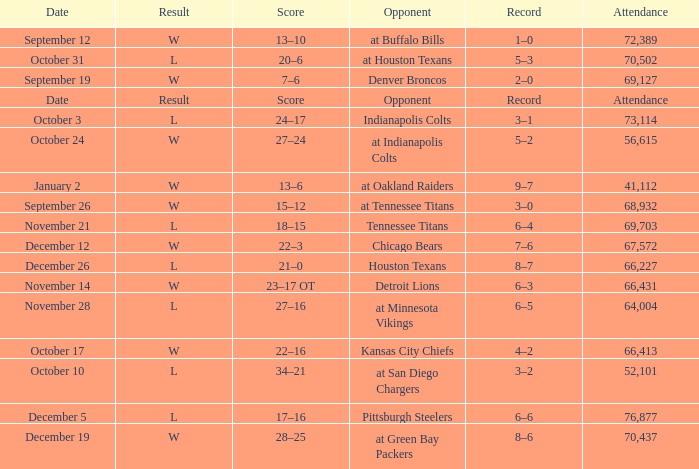Would you be able to parse every entry in this table? {'header': ['Date', 'Result', 'Score', 'Opponent', 'Record', 'Attendance'], 'rows': [['September 12', 'W', '13–10', 'at Buffalo Bills', '1–0', '72,389'], ['October 31', 'L', '20–6', 'at Houston Texans', '5–3', '70,502'], ['September 19', 'W', '7–6', 'Denver Broncos', '2–0', '69,127'], ['Date', 'Result', 'Score', 'Opponent', 'Record', 'Attendance'], ['October 3', 'L', '24–17', 'Indianapolis Colts', '3–1', '73,114'], ['October 24', 'W', '27–24', 'at Indianapolis Colts', '5–2', '56,615'], ['January 2', 'W', '13–6', 'at Oakland Raiders', '9–7', '41,112'], ['September 26', 'W', '15–12', 'at Tennessee Titans', '3–0', '68,932'], ['November 21', 'L', '18–15', 'Tennessee Titans', '6–4', '69,703'], ['December 12', 'W', '22–3', 'Chicago Bears', '7–6', '67,572'], ['December 26', 'L', '21–0', 'Houston Texans', '8–7', '66,227'], ['November 14', 'W', '23–17 OT', 'Detroit Lions', '6–3', '66,431'], ['November 28', 'L', '27–16', 'at Minnesota Vikings', '6–5', '64,004'], ['October 17', 'W', '22–16', 'Kansas City Chiefs', '4–2', '66,413'], ['October 10', 'L', '34–21', 'at San Diego Chargers', '3–2', '52,101'], ['December 5', 'L', '17–16', 'Pittsburgh Steelers', '6–6', '76,877'], ['December 19', 'W', '28–25', 'at Green Bay Packers', '8–6', '70,437']]} What attendance has detroit lions as the opponent? 66431.0. 